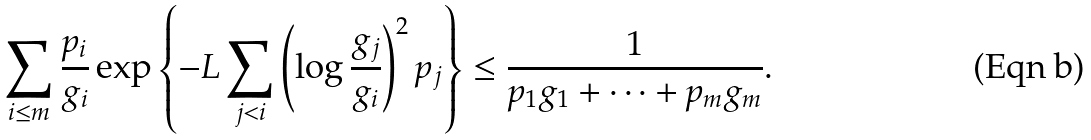<formula> <loc_0><loc_0><loc_500><loc_500>\sum _ { i \leq m } \frac { p _ { i } } { g _ { i } } \exp \left \{ - L \sum _ { j < i } \left ( \log \frac { g _ { j } } { g _ { i } } \right ) ^ { 2 } p _ { j } \right \} \leq \frac { 1 } { p _ { 1 } g _ { 1 } + \dots + p _ { m } g _ { m } } .</formula> 